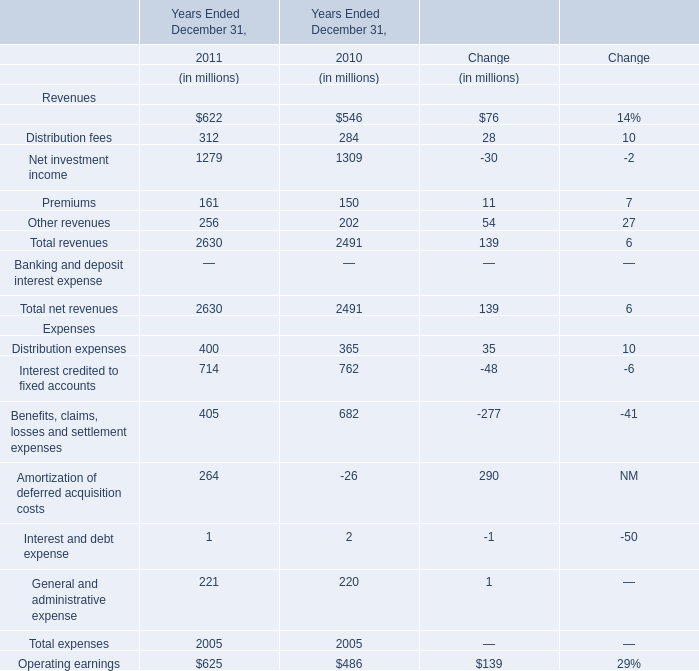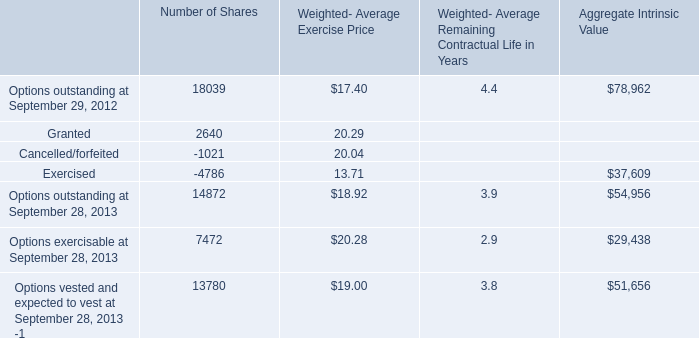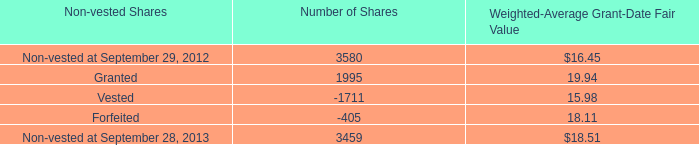In what year is Benefits, claims, losses and settlement expenses positive? 
Answer: 2010. 